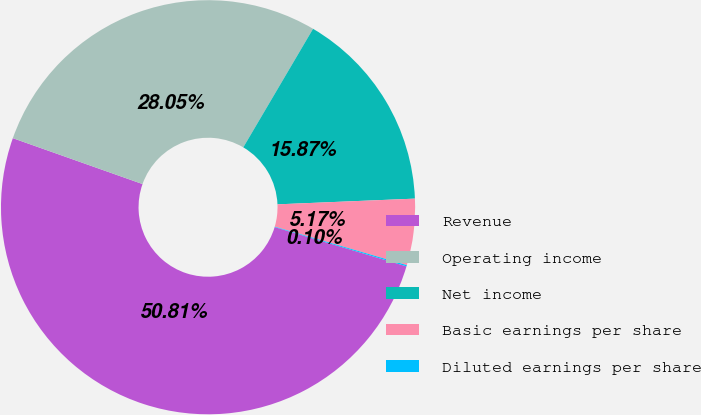<chart> <loc_0><loc_0><loc_500><loc_500><pie_chart><fcel>Revenue<fcel>Operating income<fcel>Net income<fcel>Basic earnings per share<fcel>Diluted earnings per share<nl><fcel>50.8%<fcel>28.05%<fcel>15.87%<fcel>5.17%<fcel>0.1%<nl></chart> 